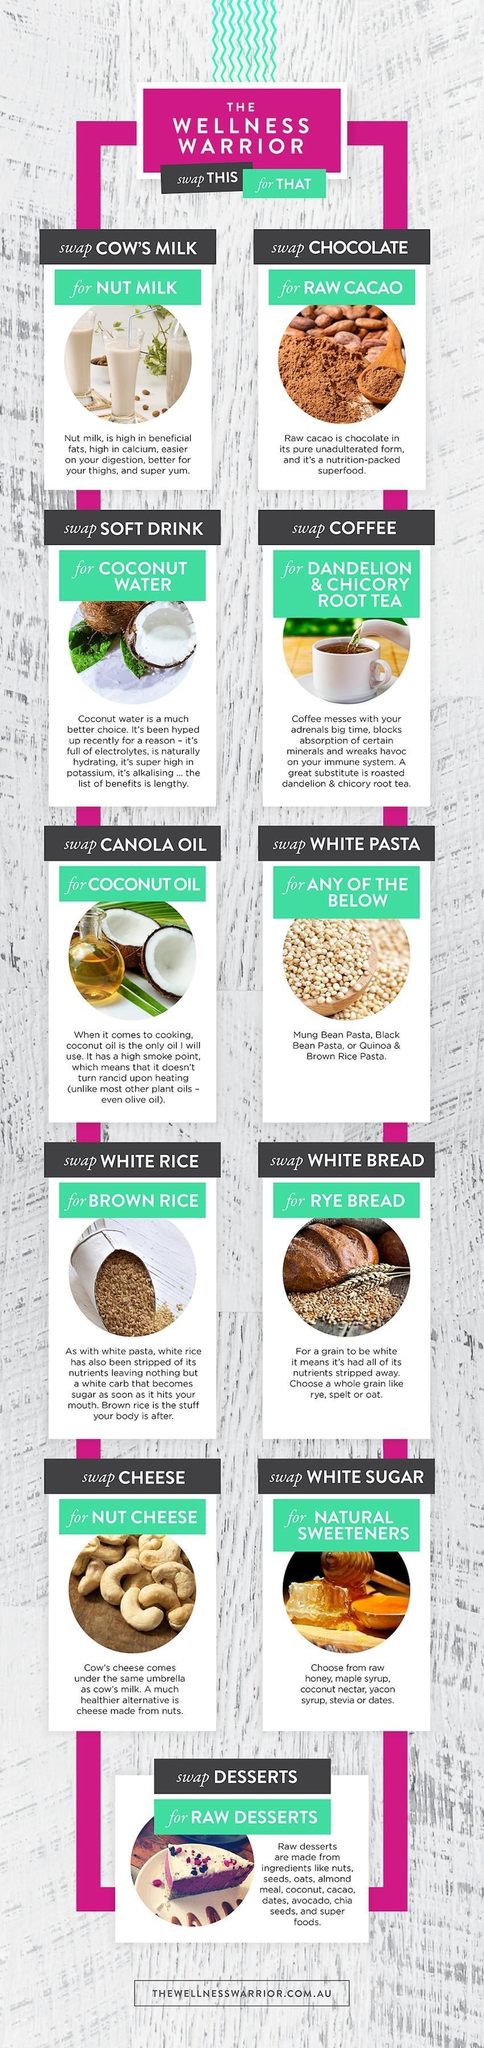Which products obtained from the cow needs to be swapped with nuts?
Answer the question with a short phrase. Cow's Milk, Cheese What needs to be replaced with Black Bean Pasta? White Pasta How many food items are listed to be swapped ? 11 Which oil has a high smoke point, Olive oil, Canola oil, or Coconut oil? Coconut Oil What can chocolate be replaced with ? Raw Cacao Which are the healthy foods obtained from coconut? Coconut water, Coconut oil 